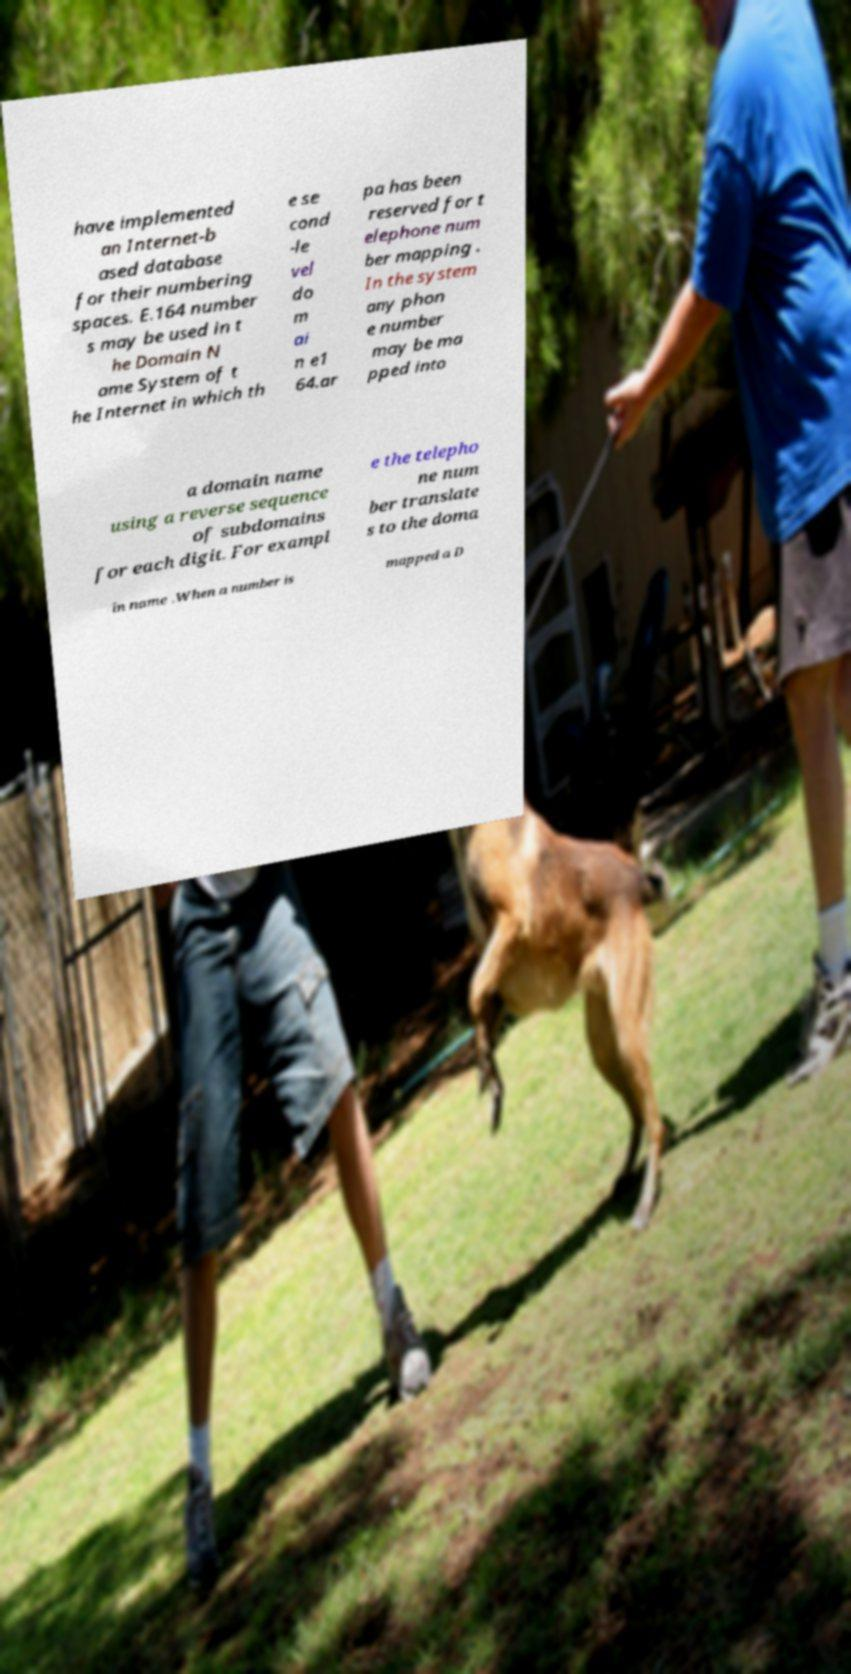What messages or text are displayed in this image? I need them in a readable, typed format. have implemented an Internet-b ased database for their numbering spaces. E.164 number s may be used in t he Domain N ame System of t he Internet in which th e se cond -le vel do m ai n e1 64.ar pa has been reserved for t elephone num ber mapping . In the system any phon e number may be ma pped into a domain name using a reverse sequence of subdomains for each digit. For exampl e the telepho ne num ber translate s to the doma in name .When a number is mapped a D 